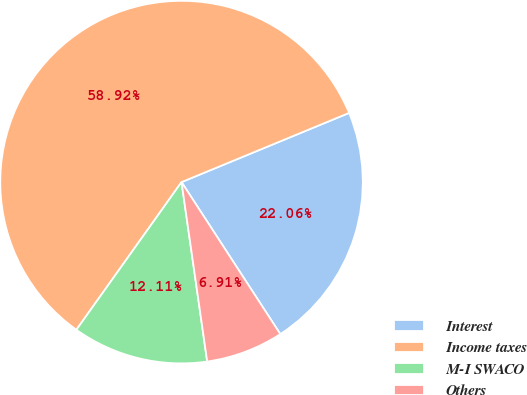Convert chart. <chart><loc_0><loc_0><loc_500><loc_500><pie_chart><fcel>Interest<fcel>Income taxes<fcel>M-I SWACO<fcel>Others<nl><fcel>22.06%<fcel>58.92%<fcel>12.11%<fcel>6.91%<nl></chart> 